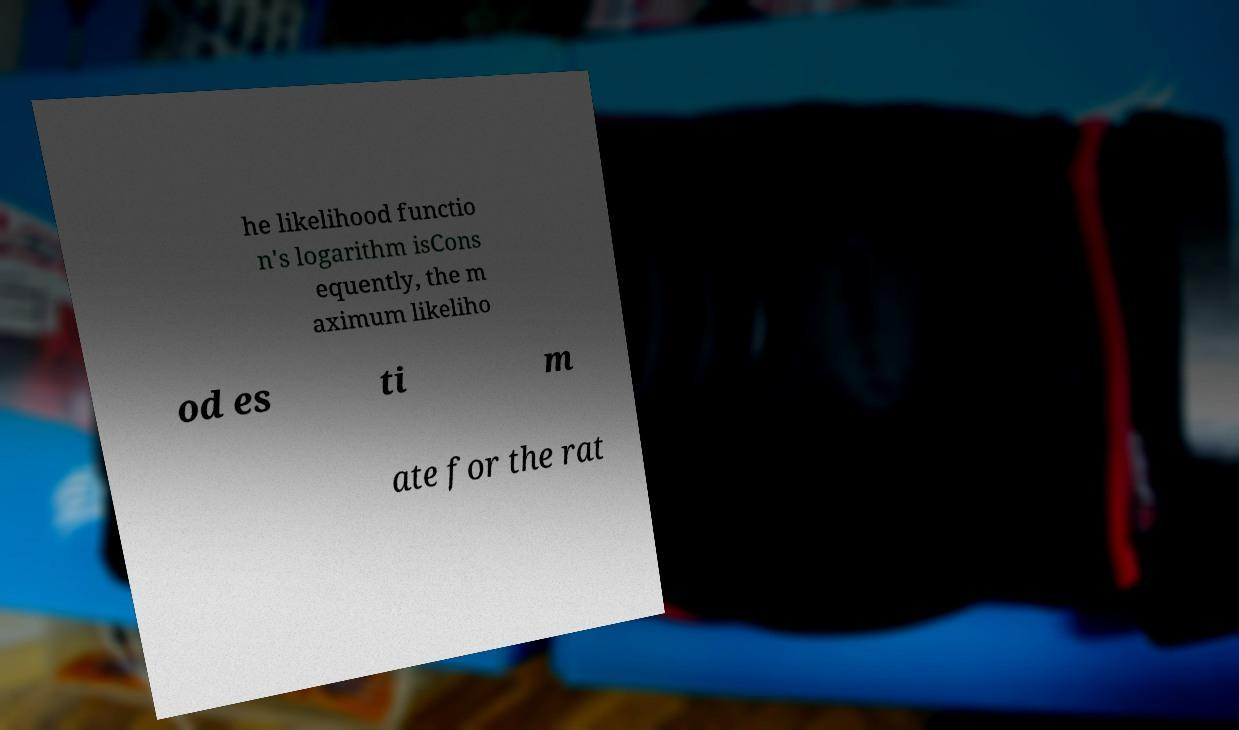Can you read and provide the text displayed in the image?This photo seems to have some interesting text. Can you extract and type it out for me? he likelihood functio n's logarithm isCons equently, the m aximum likeliho od es ti m ate for the rat 